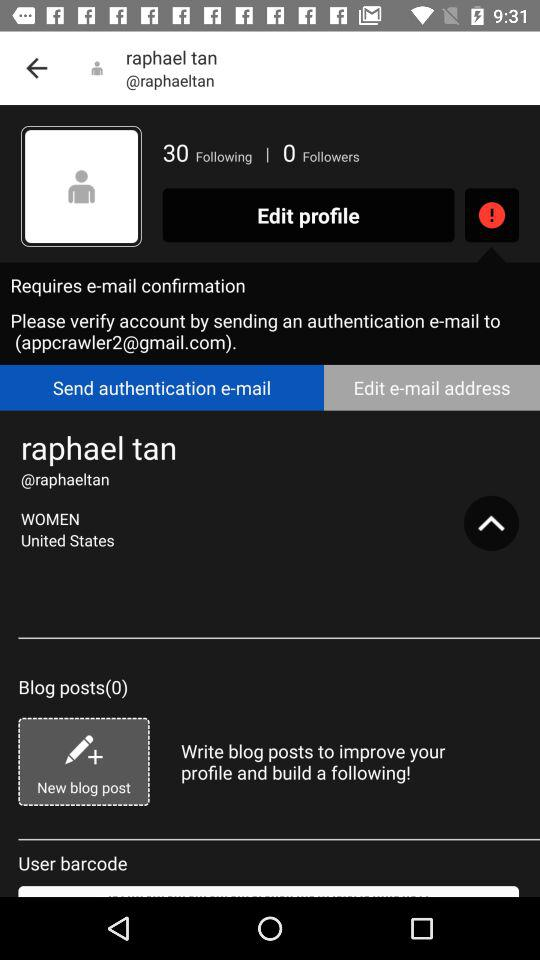How many blog posts have been posted? There have been 0 blog posts posted. 